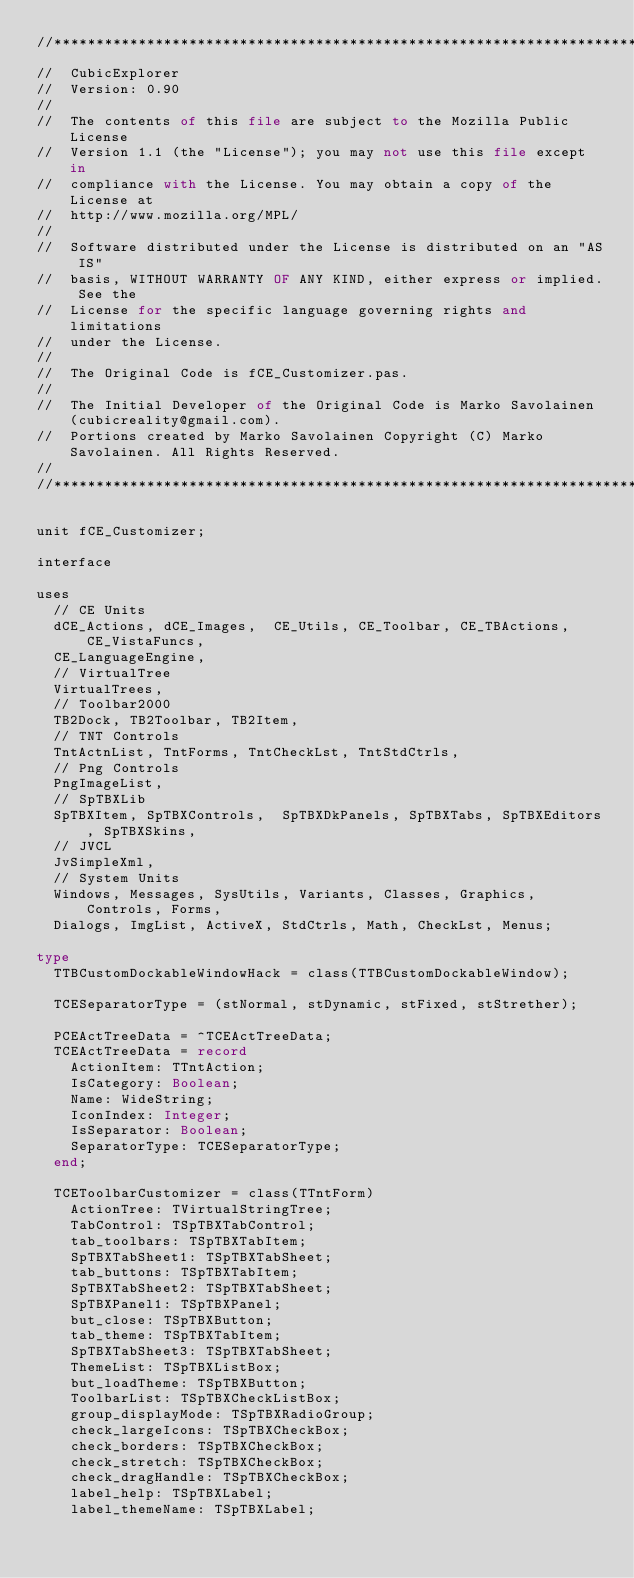Convert code to text. <code><loc_0><loc_0><loc_500><loc_500><_Pascal_>//******************************************************************************
//  CubicExplorer                                                                             
//  Version: 0.90                                                                             
//                                                                                            
//  The contents of this file are subject to the Mozilla Public License                       
//  Version 1.1 (the "License"); you may not use this file except in                          
//  compliance with the License. You may obtain a copy of the License at                      
//  http://www.mozilla.org/MPL/                                                               
//                                                                                            
//  Software distributed under the License is distributed on an "AS IS"
//  basis, WITHOUT WARRANTY OF ANY KIND, either express or implied. See the
//  License for the specific language governing rights and limitations                        
//  under the License.                                                                        
//                                                                                            
//  The Original Code is fCE_Customizer.pas.                                                            
//                                                                                            
//  The Initial Developer of the Original Code is Marko Savolainen (cubicreality@gmail.com).  
//  Portions created by Marko Savolainen Copyright (C) Marko Savolainen. All Rights Reserved. 
//                                                                                            
//******************************************************************************

unit fCE_Customizer;

interface

uses
  // CE Units
  dCE_Actions, dCE_Images,  CE_Utils, CE_Toolbar, CE_TBActions, CE_VistaFuncs,
  CE_LanguageEngine,
  // VirtualTree
  VirtualTrees,
  // Toolbar2000
  TB2Dock, TB2Toolbar, TB2Item,
  // TNT Controls
  TntActnList, TntForms, TntCheckLst, TntStdCtrls,
  // Png Controls
  PngImageList,
  // SpTBXLib
  SpTBXItem, SpTBXControls,  SpTBXDkPanels, SpTBXTabs, SpTBXEditors, SpTBXSkins,
  // JVCL
  JvSimpleXml,
  // System Units
  Windows, Messages, SysUtils, Variants, Classes, Graphics, Controls, Forms,
  Dialogs, ImgList, ActiveX, StdCtrls, Math, CheckLst, Menus;

type
  TTBCustomDockableWindowHack = class(TTBCustomDockableWindow);

  TCESeparatorType = (stNormal, stDynamic, stFixed, stStrether);

  PCEActTreeData = ^TCEActTreeData;
  TCEActTreeData = record
    ActionItem: TTntAction;
    IsCategory: Boolean;
    Name: WideString;
    IconIndex: Integer;
    IsSeparator: Boolean;
    SeparatorType: TCESeparatorType;
  end;

  TCEToolbarCustomizer = class(TTntForm)
    ActionTree: TVirtualStringTree;
    TabControl: TSpTBXTabControl;
    tab_toolbars: TSpTBXTabItem;
    SpTBXTabSheet1: TSpTBXTabSheet;
    tab_buttons: TSpTBXTabItem;
    SpTBXTabSheet2: TSpTBXTabSheet;
    SpTBXPanel1: TSpTBXPanel;
    but_close: TSpTBXButton;
    tab_theme: TSpTBXTabItem;
    SpTBXTabSheet3: TSpTBXTabSheet;
    ThemeList: TSpTBXListBox;
    but_loadTheme: TSpTBXButton;
    ToolbarList: TSpTBXCheckListBox;
    group_displayMode: TSpTBXRadioGroup;
    check_largeIcons: TSpTBXCheckBox;
    check_borders: TSpTBXCheckBox;
    check_stretch: TSpTBXCheckBox;
    check_dragHandle: TSpTBXCheckBox;
    label_help: TSpTBXLabel;
    label_themeName: TSpTBXLabel;</code> 